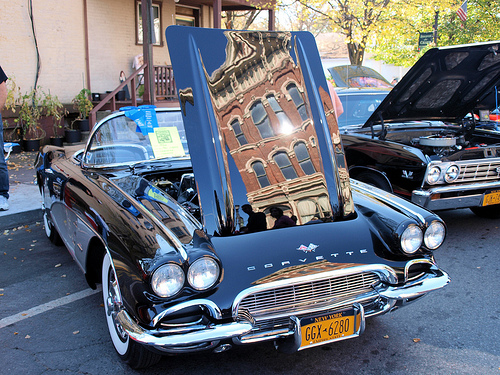<image>
Is there a house on the car? No. The house is not positioned on the car. They may be near each other, but the house is not supported by or resting on top of the car. Is there a person behind the car? Yes. From this viewpoint, the person is positioned behind the car, with the car partially or fully occluding the person. 